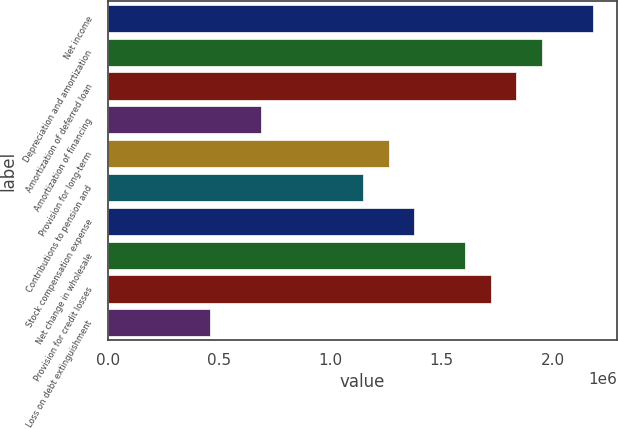Convert chart. <chart><loc_0><loc_0><loc_500><loc_500><bar_chart><fcel>Net income<fcel>Depreciation and amortization<fcel>Amortization of deferred loan<fcel>Amortization of financing<fcel>Provision for long-term<fcel>Contributions to pension and<fcel>Stock compensation expense<fcel>Net change in wholesale<fcel>Provision for credit losses<fcel>Loss on debt extinguishment<nl><fcel>2.17805e+06<fcel>1.94886e+06<fcel>1.83426e+06<fcel>688287<fcel>1.26127e+06<fcel>1.14668e+06<fcel>1.37587e+06<fcel>1.60507e+06<fcel>1.71966e+06<fcel>459093<nl></chart> 